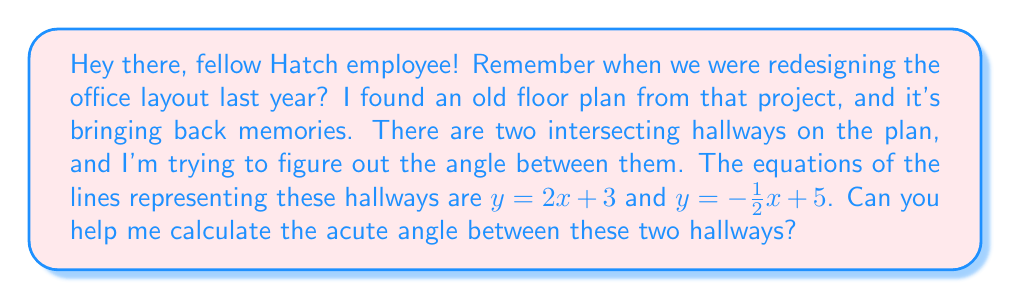Give your solution to this math problem. Certainly! Let's walk through this step-by-step:

1) To find the angle between two lines, we can use the formula:

   $$\tan \theta = \left|\frac{m_1 - m_2}{1 + m_1m_2}\right|$$

   where $m_1$ and $m_2$ are the slopes of the two lines, and $\theta$ is the acute angle between them.

2) From the given equations:
   - For $y = 2x + 3$, the slope $m_1 = 2$
   - For $y = -\frac{1}{2}x + 5$, the slope $m_2 = -\frac{1}{2}$

3) Let's substitute these into our formula:

   $$\tan \theta = \left|\frac{2 - (-\frac{1}{2})}{1 + 2(-\frac{1}{2})}\right|$$

4) Simplify the numerator and denominator:

   $$\tan \theta = \left|\frac{2 + \frac{1}{2}}{1 - 1}\right| = \left|\frac{\frac{5}{2}}{0}\right|$$

5) Simplify further:

   $$\tan \theta = \frac{5}{2} = 2.5$$

6) To find $\theta$, we need to take the inverse tangent (arctan) of both sides:

   $$\theta = \arctan(2.5)$$

7) Using a calculator or computer, we can find:

   $$\theta \approx 1.1902 \text{ radians}$$

8) To convert to degrees, multiply by $\frac{180}{\pi}$:

   $$\theta \approx 1.1902 \times \frac{180}{\pi} \approx 68.20°$$

Therefore, the acute angle between the two hallways is approximately 68.20°.
Answer: The acute angle between the two intersecting hallways is approximately 68.20°. 